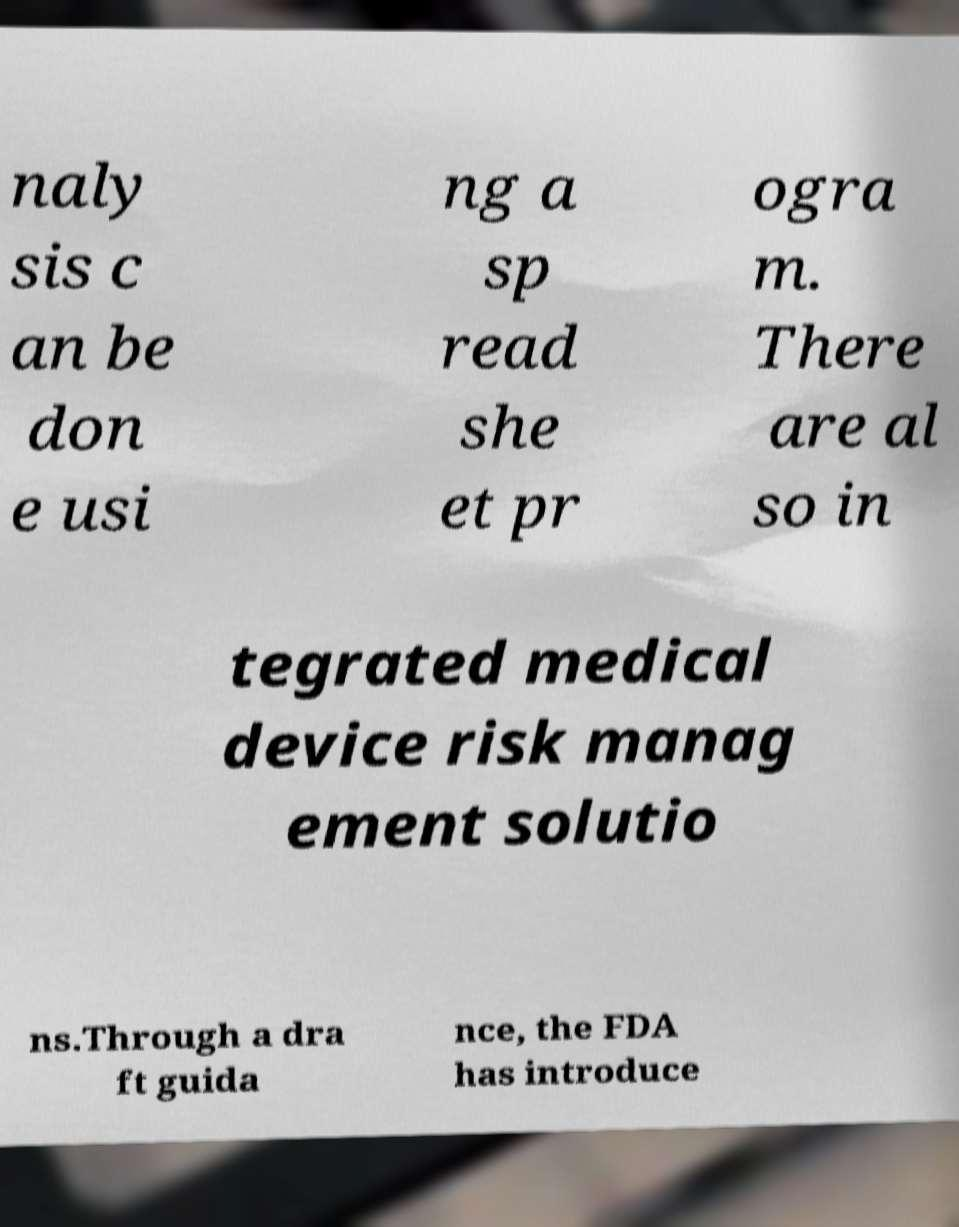There's text embedded in this image that I need extracted. Can you transcribe it verbatim? naly sis c an be don e usi ng a sp read she et pr ogra m. There are al so in tegrated medical device risk manag ement solutio ns.Through a dra ft guida nce, the FDA has introduce 